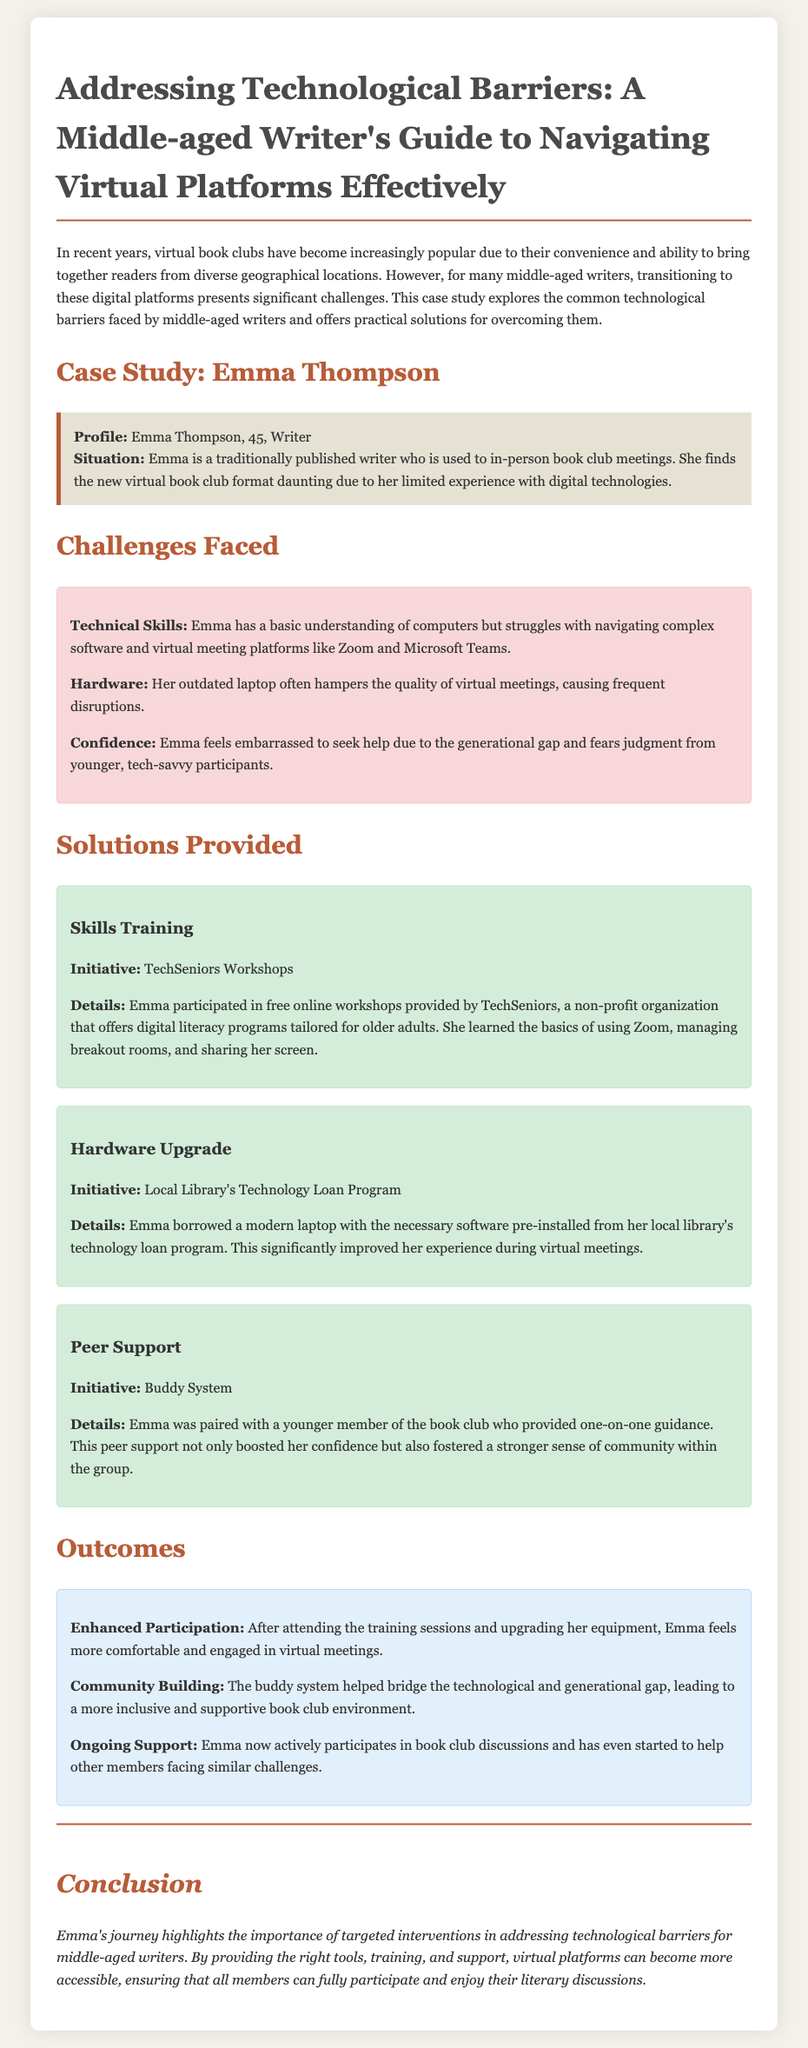What is the name of the writer in the case study? The name of the writer is mentioned at the beginning of the case study.
Answer: Emma Thompson What is Emma's age? Emma's age is provided in the profile section of the case study.
Answer: 45 What technology training program did Emma participate in? The training program is specified in the solutions provided for Emma's challenges.
Answer: TechSeniors Workshops What hardware initiative did Emma use for her technology upgrade? The specific initiative for hardware upgrade is mentioned in the solutions section.
Answer: Local Library's Technology Loan Program Who provided one-on-one guidance to Emma? The document specifies the type of support Emma received.
Answer: A younger member of the book club Which virtual meeting platforms did Emma struggle with? The platforms are listed in the challenges faced by Emma.
Answer: Zoom and Microsoft Teams What was one significant outcome of Emma's participation in workshops? The outcomes are detailed in the outcomes section of the case study.
Answer: Enhanced Participation What benefit did the buddy system provide? The purpose and outcome of the buddy system are outlined in the solutions section.
Answer: Peer support What was a notable community benefit from Emma's experience? The community benefit is mentioned under the outcomes section.
Answer: Community Building 